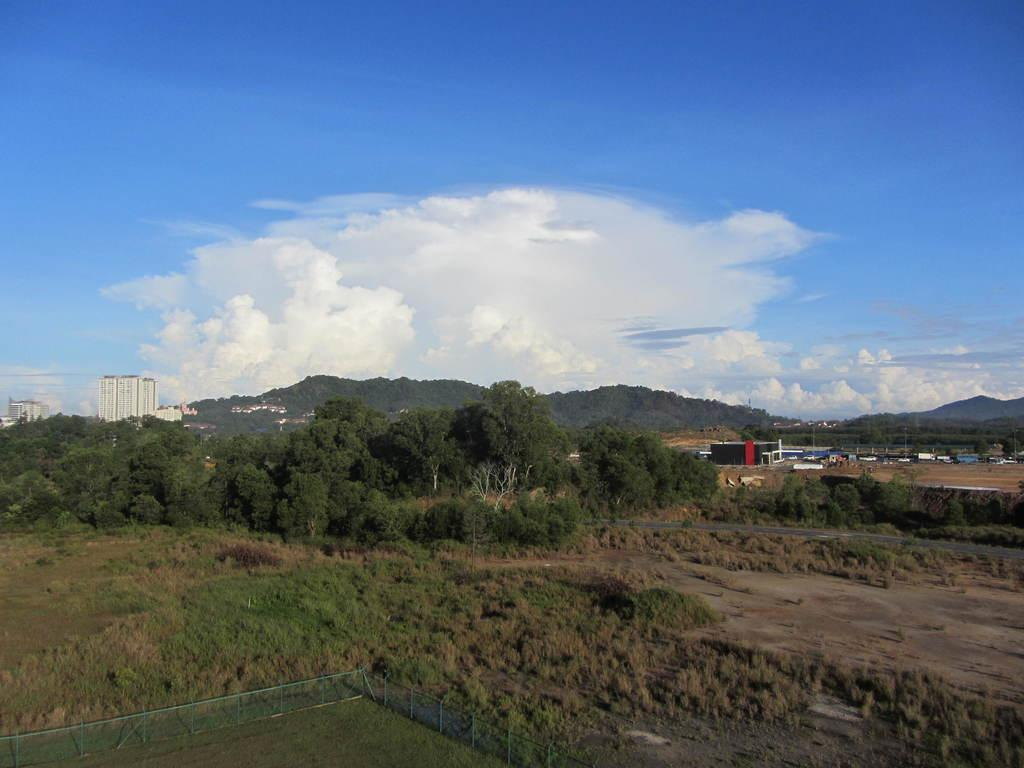What type of vegetation is present in the image? There is grass and plants in the image. What type of structures can be seen in the image? There are buildings in the image. What other natural elements are visible in the image? There are trees and hills in the image. What part of the natural environment is visible in the image? The sky is visible in the image. What type of food is the cook preparing in the image? There is no cook or food preparation visible in the image. What message of peace is being conveyed in the image? There is no message of peace or any indication of a peace-related theme in the image. 